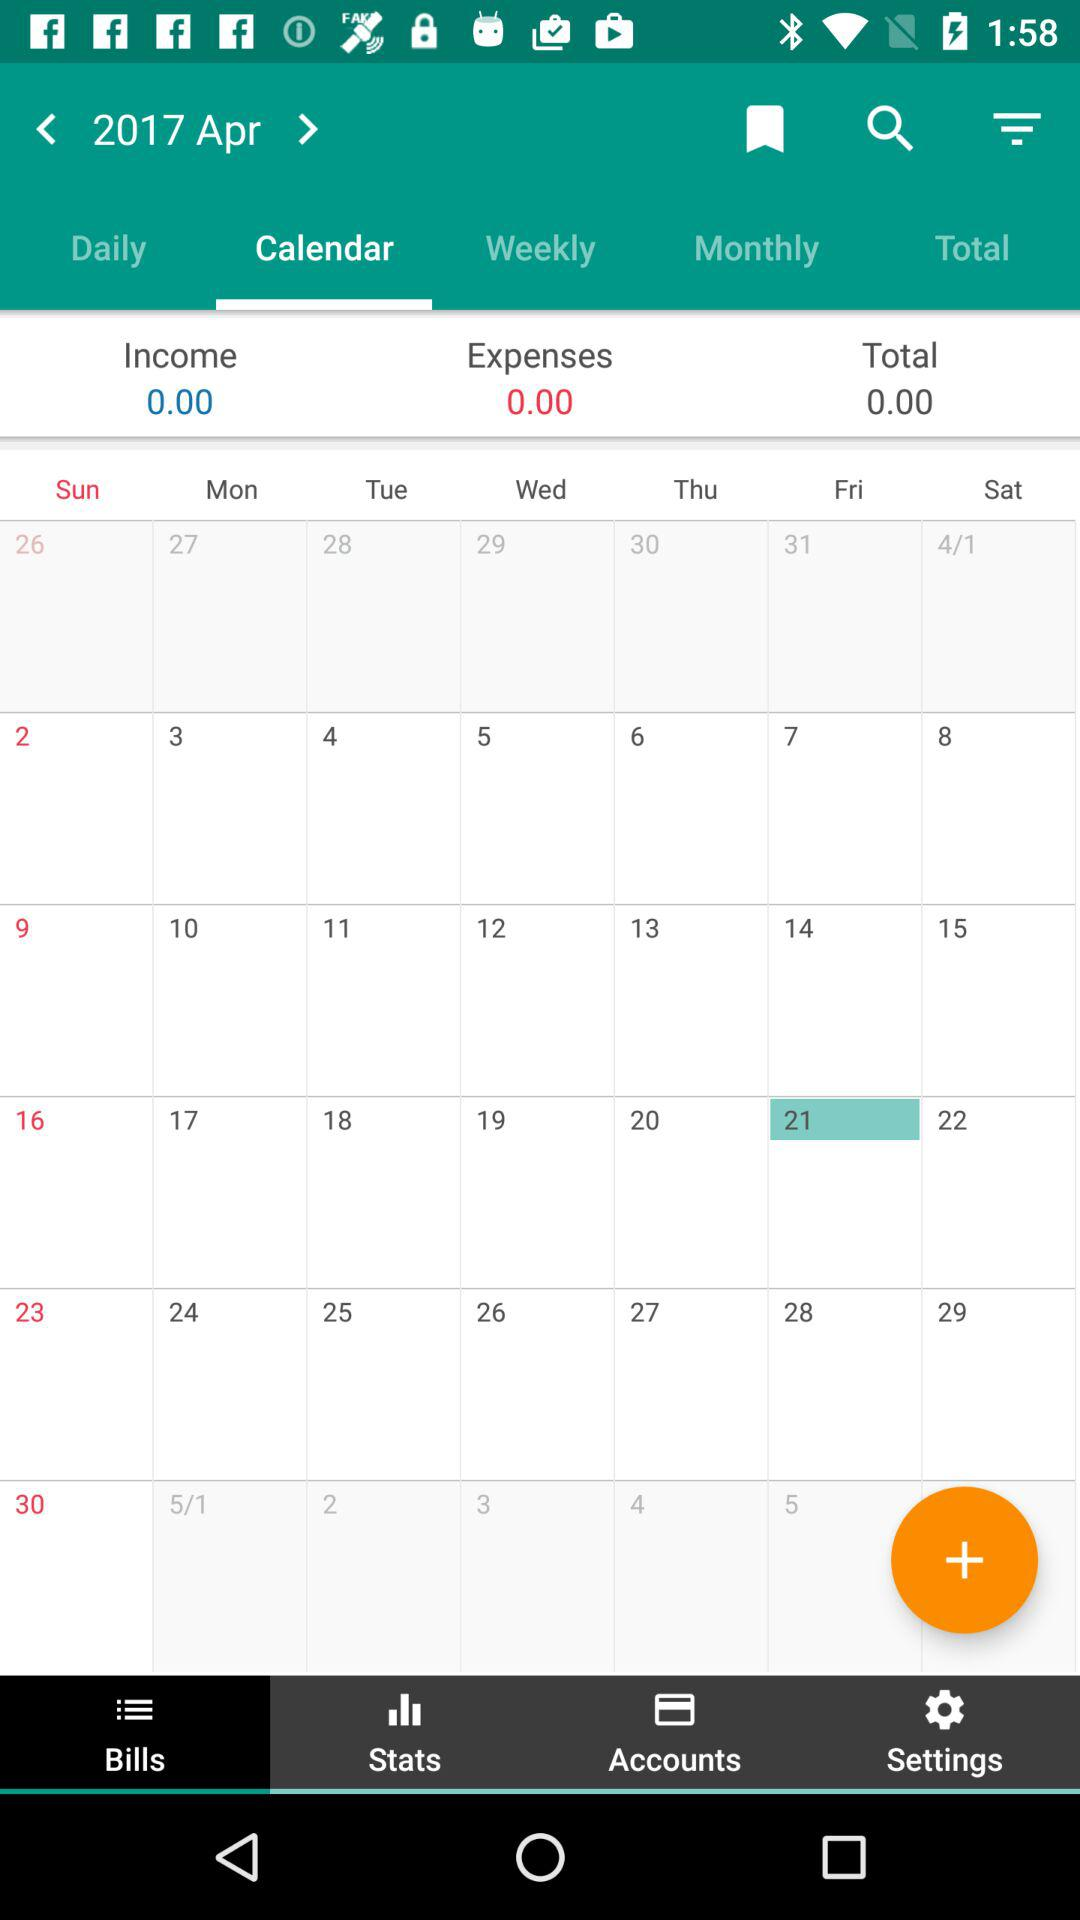Which tab has been selected in the bottom row? The tab that has been selected in the bottom row is "Bills". 